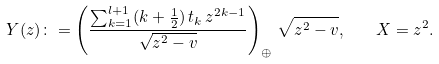<formula> <loc_0><loc_0><loc_500><loc_500>Y ( z ) \colon = \left ( \frac { \sum _ { k = 1 } ^ { l + 1 } ( k + \frac { 1 } { 2 } ) \, t _ { k } \, z ^ { 2 k - 1 } } { \sqrt { z ^ { 2 } - v } } \right ) _ { \oplus } \, \sqrt { z ^ { 2 } - v } , \quad X = z ^ { 2 } .</formula> 